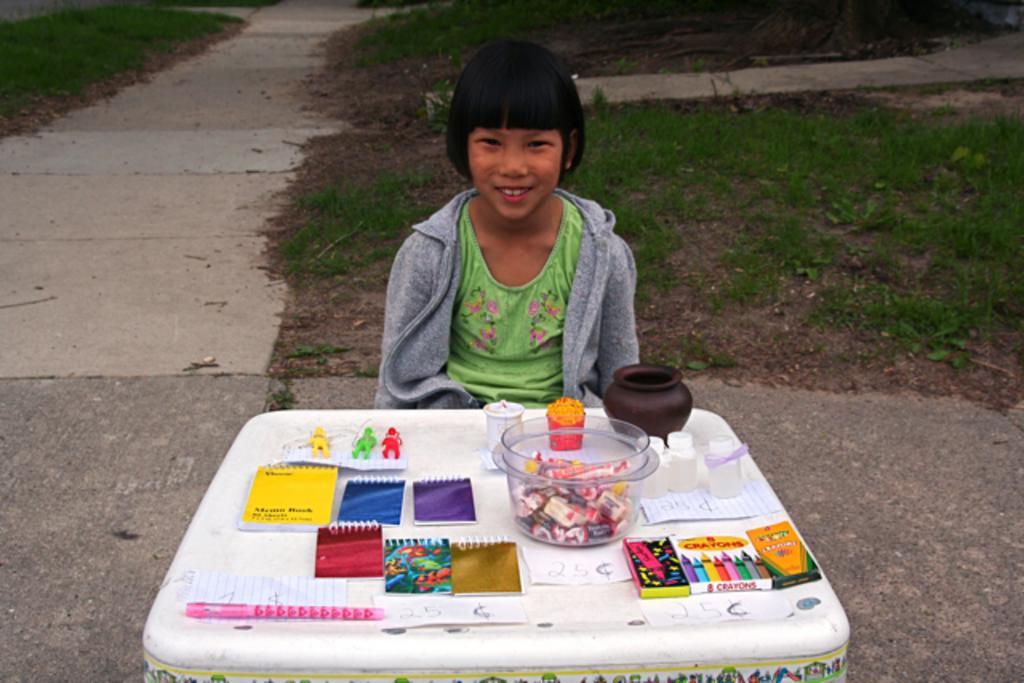How would you summarize this image in a sentence or two? In this image there is a person wearing a smile on her face. In front of her there is a table. On top of it there are chocolates in a tub. There is a pot. There are books. There is a pen and a few other objects. On the left side of the image there is a road. In the background of the image there is grass on the surface. 